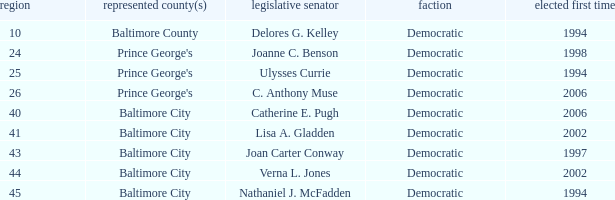What district for ulysses currie? 25.0. 